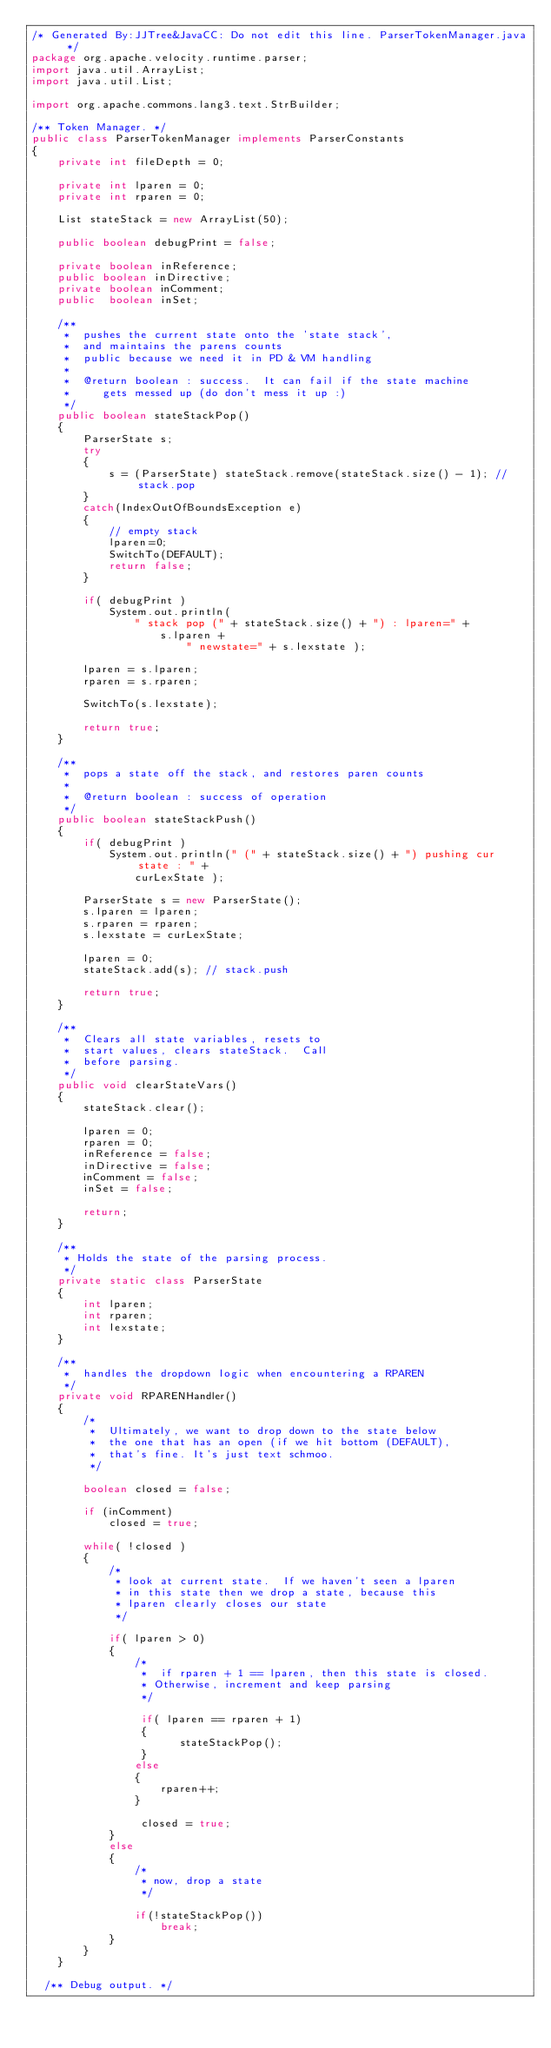<code> <loc_0><loc_0><loc_500><loc_500><_Java_>/* Generated By:JJTree&JavaCC: Do not edit this line. ParserTokenManager.java */
package org.apache.velocity.runtime.parser;
import java.util.ArrayList;
import java.util.List;

import org.apache.commons.lang3.text.StrBuilder;

/** Token Manager. */
public class ParserTokenManager implements ParserConstants
{
    private int fileDepth = 0;

    private int lparen = 0;
    private int rparen = 0;

    List stateStack = new ArrayList(50);

    public boolean debugPrint = false;

    private boolean inReference;
    public boolean inDirective;
    private boolean inComment;
    public  boolean inSet;

    /**
     *  pushes the current state onto the 'state stack',
     *  and maintains the parens counts
     *  public because we need it in PD & VM handling
     *
     *  @return boolean : success.  It can fail if the state machine
     *     gets messed up (do don't mess it up :)
     */
    public boolean stateStackPop()
    {
        ParserState s;
        try
        {
            s = (ParserState) stateStack.remove(stateStack.size() - 1); // stack.pop
        }
        catch(IndexOutOfBoundsException e)
        {
            // empty stack
            lparen=0;
            SwitchTo(DEFAULT);
            return false;
        }

        if( debugPrint )
            System.out.println(
                " stack pop (" + stateStack.size() + ") : lparen=" +
                    s.lparen +
                        " newstate=" + s.lexstate );

        lparen = s.lparen;
        rparen = s.rparen;

        SwitchTo(s.lexstate);

        return true;
    }

    /**
     *  pops a state off the stack, and restores paren counts
     *
     *  @return boolean : success of operation
     */
    public boolean stateStackPush()
    {
        if( debugPrint )
            System.out.println(" (" + stateStack.size() + ") pushing cur state : " +
                curLexState );

        ParserState s = new ParserState();
        s.lparen = lparen;
        s.rparen = rparen;
        s.lexstate = curLexState;

        lparen = 0;
        stateStack.add(s); // stack.push

        return true;
    }

    /**
     *  Clears all state variables, resets to
     *  start values, clears stateStack.  Call
     *  before parsing.
     */
    public void clearStateVars()
    {
        stateStack.clear();

        lparen = 0;
        rparen = 0;
        inReference = false;
        inDirective = false;
        inComment = false;
        inSet = false;

        return;
    }

    /**
     * Holds the state of the parsing process.
     */
    private static class ParserState
    {
        int lparen;
        int rparen;
        int lexstate;
    }

    /**
     *  handles the dropdown logic when encountering a RPAREN
     */
    private void RPARENHandler()
    {
        /*
         *  Ultimately, we want to drop down to the state below
         *  the one that has an open (if we hit bottom (DEFAULT),
         *  that's fine. It's just text schmoo.
         */

        boolean closed = false;

        if (inComment)
            closed = true;

        while( !closed )
        {
            /*
             * look at current state.  If we haven't seen a lparen
             * in this state then we drop a state, because this
             * lparen clearly closes our state
             */

            if( lparen > 0)
            {
                /*
                 *  if rparen + 1 == lparen, then this state is closed.
                 * Otherwise, increment and keep parsing
                 */

                 if( lparen == rparen + 1)
                 {
                       stateStackPop();
                 }
                else
                {
                    rparen++;
                }

                 closed = true;
            }
            else
            {
                /*
                 * now, drop a state
                 */

                if(!stateStackPop())
                    break;
            }
        }
    }

  /** Debug output. */</code> 